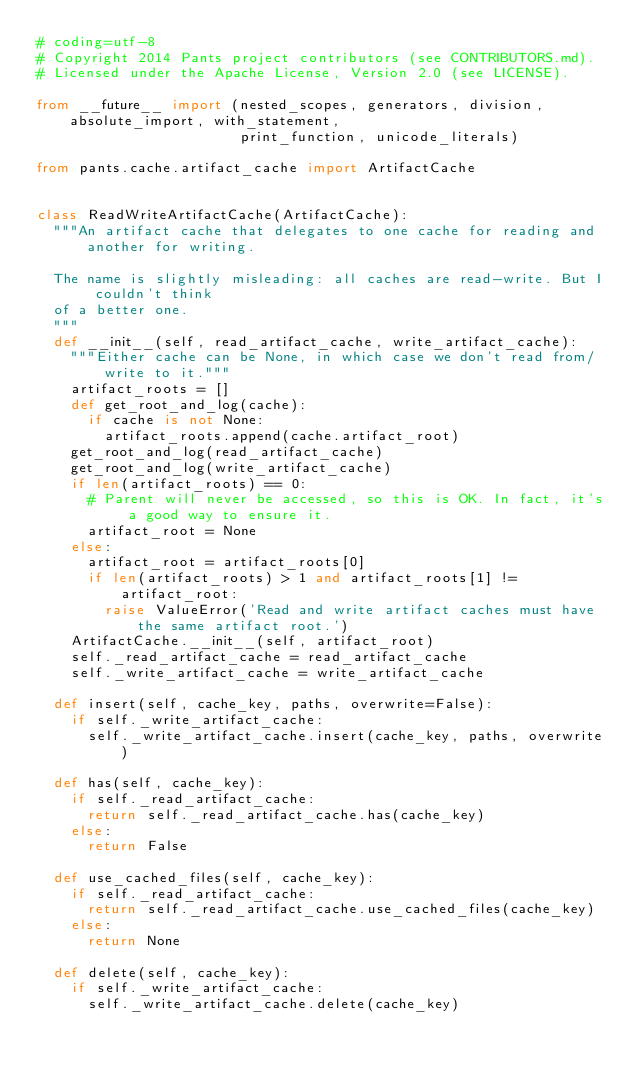<code> <loc_0><loc_0><loc_500><loc_500><_Python_># coding=utf-8
# Copyright 2014 Pants project contributors (see CONTRIBUTORS.md).
# Licensed under the Apache License, Version 2.0 (see LICENSE).

from __future__ import (nested_scopes, generators, division, absolute_import, with_statement,
                        print_function, unicode_literals)

from pants.cache.artifact_cache import ArtifactCache


class ReadWriteArtifactCache(ArtifactCache):
  """An artifact cache that delegates to one cache for reading and another for writing.

  The name is slightly misleading: all caches are read-write. But I couldn't think
  of a better one.
  """
  def __init__(self, read_artifact_cache, write_artifact_cache):
    """Either cache can be None, in which case we don't read from/write to it."""
    artifact_roots = []
    def get_root_and_log(cache):
      if cache is not None:
        artifact_roots.append(cache.artifact_root)
    get_root_and_log(read_artifact_cache)
    get_root_and_log(write_artifact_cache)
    if len(artifact_roots) == 0:
      # Parent will never be accessed, so this is OK. In fact, it's a good way to ensure it.
      artifact_root = None
    else:
      artifact_root = artifact_roots[0]
      if len(artifact_roots) > 1 and artifact_roots[1] != artifact_root:
        raise ValueError('Read and write artifact caches must have the same artifact root.')
    ArtifactCache.__init__(self, artifact_root)
    self._read_artifact_cache = read_artifact_cache
    self._write_artifact_cache = write_artifact_cache

  def insert(self, cache_key, paths, overwrite=False):
    if self._write_artifact_cache:
      self._write_artifact_cache.insert(cache_key, paths, overwrite)

  def has(self, cache_key):
    if self._read_artifact_cache:
      return self._read_artifact_cache.has(cache_key)
    else:
      return False

  def use_cached_files(self, cache_key):
    if self._read_artifact_cache:
      return self._read_artifact_cache.use_cached_files(cache_key)
    else:
      return None

  def delete(self, cache_key):
    if self._write_artifact_cache:
      self._write_artifact_cache.delete(cache_key)
</code> 